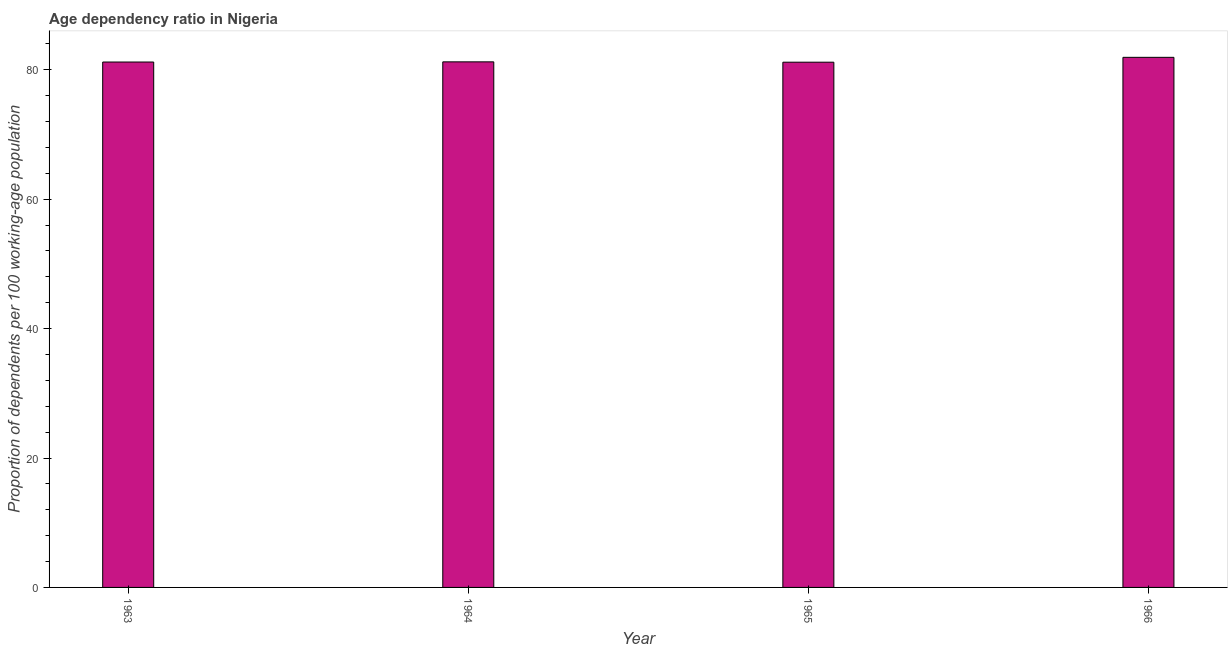Does the graph contain grids?
Provide a succinct answer. No. What is the title of the graph?
Offer a very short reply. Age dependency ratio in Nigeria. What is the label or title of the Y-axis?
Offer a very short reply. Proportion of dependents per 100 working-age population. What is the age dependency ratio in 1963?
Provide a short and direct response. 81.2. Across all years, what is the maximum age dependency ratio?
Offer a terse response. 81.93. Across all years, what is the minimum age dependency ratio?
Ensure brevity in your answer.  81.17. In which year was the age dependency ratio maximum?
Offer a very short reply. 1966. In which year was the age dependency ratio minimum?
Ensure brevity in your answer.  1965. What is the sum of the age dependency ratio?
Offer a very short reply. 325.53. What is the difference between the age dependency ratio in 1963 and 1966?
Your response must be concise. -0.72. What is the average age dependency ratio per year?
Give a very brief answer. 81.38. What is the median age dependency ratio?
Your answer should be compact. 81.21. What is the ratio of the age dependency ratio in 1963 to that in 1966?
Provide a succinct answer. 0.99. Is the difference between the age dependency ratio in 1963 and 1965 greater than the difference between any two years?
Keep it short and to the point. No. What is the difference between the highest and the second highest age dependency ratio?
Keep it short and to the point. 0.7. What is the difference between the highest and the lowest age dependency ratio?
Your response must be concise. 0.75. In how many years, is the age dependency ratio greater than the average age dependency ratio taken over all years?
Keep it short and to the point. 1. How many years are there in the graph?
Make the answer very short. 4. Are the values on the major ticks of Y-axis written in scientific E-notation?
Provide a succinct answer. No. What is the Proportion of dependents per 100 working-age population in 1963?
Make the answer very short. 81.2. What is the Proportion of dependents per 100 working-age population of 1964?
Your response must be concise. 81.23. What is the Proportion of dependents per 100 working-age population in 1965?
Ensure brevity in your answer.  81.17. What is the Proportion of dependents per 100 working-age population of 1966?
Provide a short and direct response. 81.93. What is the difference between the Proportion of dependents per 100 working-age population in 1963 and 1964?
Make the answer very short. -0.03. What is the difference between the Proportion of dependents per 100 working-age population in 1963 and 1965?
Make the answer very short. 0.03. What is the difference between the Proportion of dependents per 100 working-age population in 1963 and 1966?
Your answer should be very brief. -0.72. What is the difference between the Proportion of dependents per 100 working-age population in 1964 and 1965?
Provide a short and direct response. 0.05. What is the difference between the Proportion of dependents per 100 working-age population in 1964 and 1966?
Your answer should be very brief. -0.7. What is the difference between the Proportion of dependents per 100 working-age population in 1965 and 1966?
Provide a short and direct response. -0.75. What is the ratio of the Proportion of dependents per 100 working-age population in 1963 to that in 1964?
Provide a short and direct response. 1. What is the ratio of the Proportion of dependents per 100 working-age population in 1963 to that in 1965?
Give a very brief answer. 1. What is the ratio of the Proportion of dependents per 100 working-age population in 1963 to that in 1966?
Make the answer very short. 0.99. 